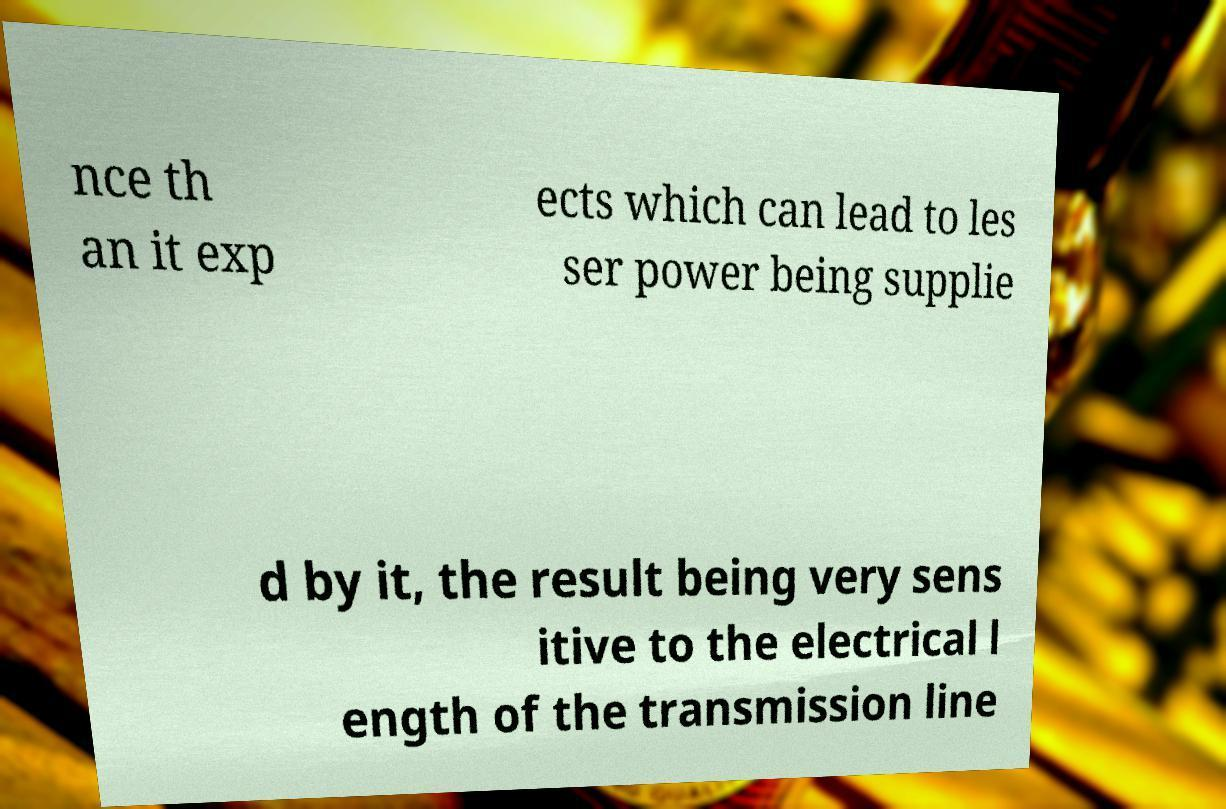Can you accurately transcribe the text from the provided image for me? nce th an it exp ects which can lead to les ser power being supplie d by it, the result being very sens itive to the electrical l ength of the transmission line 